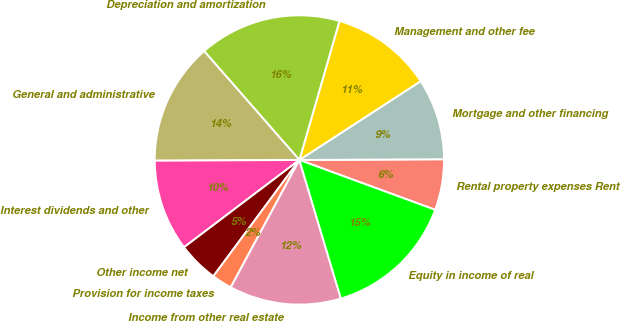Convert chart. <chart><loc_0><loc_0><loc_500><loc_500><pie_chart><fcel>Rental property expenses Rent<fcel>Mortgage and other financing<fcel>Management and other fee<fcel>Depreciation and amortization<fcel>General and administrative<fcel>Interest dividends and other<fcel>Other income net<fcel>Provision for income taxes<fcel>Income from other real estate<fcel>Equity in income of real<nl><fcel>5.68%<fcel>9.09%<fcel>11.36%<fcel>15.91%<fcel>13.64%<fcel>10.23%<fcel>4.55%<fcel>2.27%<fcel>12.5%<fcel>14.77%<nl></chart> 